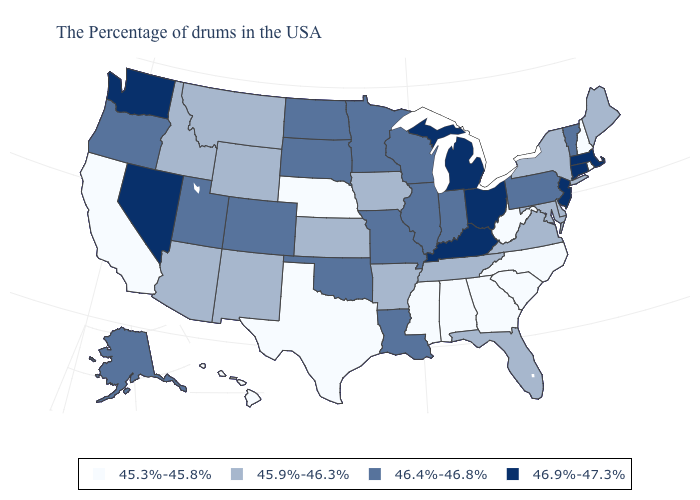Does Nevada have a higher value than Oklahoma?
Write a very short answer. Yes. What is the value of Pennsylvania?
Quick response, please. 46.4%-46.8%. Which states have the lowest value in the USA?
Keep it brief. Rhode Island, New Hampshire, North Carolina, South Carolina, West Virginia, Georgia, Alabama, Mississippi, Nebraska, Texas, California, Hawaii. Does New York have a lower value than Florida?
Give a very brief answer. No. Name the states that have a value in the range 45.9%-46.3%?
Give a very brief answer. Maine, New York, Delaware, Maryland, Virginia, Florida, Tennessee, Arkansas, Iowa, Kansas, Wyoming, New Mexico, Montana, Arizona, Idaho. Name the states that have a value in the range 46.9%-47.3%?
Be succinct. Massachusetts, Connecticut, New Jersey, Ohio, Michigan, Kentucky, Nevada, Washington. Among the states that border Iowa , does Nebraska have the highest value?
Keep it brief. No. Does Wyoming have a lower value than Connecticut?
Give a very brief answer. Yes. What is the value of New York?
Give a very brief answer. 45.9%-46.3%. Is the legend a continuous bar?
Answer briefly. No. Does Oklahoma have the same value as Colorado?
Quick response, please. Yes. Name the states that have a value in the range 45.9%-46.3%?
Write a very short answer. Maine, New York, Delaware, Maryland, Virginia, Florida, Tennessee, Arkansas, Iowa, Kansas, Wyoming, New Mexico, Montana, Arizona, Idaho. Does Tennessee have the lowest value in the South?
Answer briefly. No. What is the highest value in the South ?
Keep it brief. 46.9%-47.3%. What is the value of South Dakota?
Keep it brief. 46.4%-46.8%. 